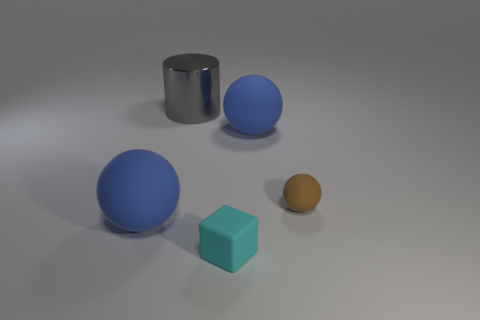Subtract all large blue rubber spheres. How many spheres are left? 1 Add 4 big brown rubber blocks. How many objects exist? 9 Subtract all brown spheres. How many spheres are left? 2 Subtract all cylinders. How many objects are left? 4 Subtract all cyan spheres. Subtract all blue blocks. How many spheres are left? 3 Subtract all yellow cylinders. How many blue balls are left? 2 Subtract all small objects. Subtract all gray metal objects. How many objects are left? 2 Add 1 things. How many things are left? 6 Add 2 large cylinders. How many large cylinders exist? 3 Subtract 0 purple cylinders. How many objects are left? 5 